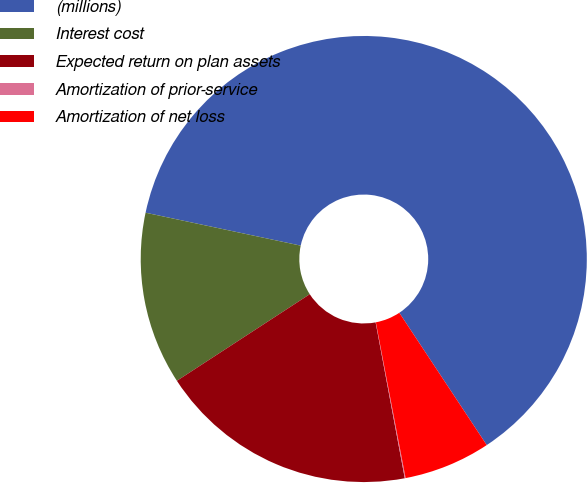<chart> <loc_0><loc_0><loc_500><loc_500><pie_chart><fcel>(millions)<fcel>Interest cost<fcel>Expected return on plan assets<fcel>Amortization of prior-service<fcel>Amortization of net loss<nl><fcel>62.37%<fcel>12.52%<fcel>18.75%<fcel>0.06%<fcel>6.29%<nl></chart> 